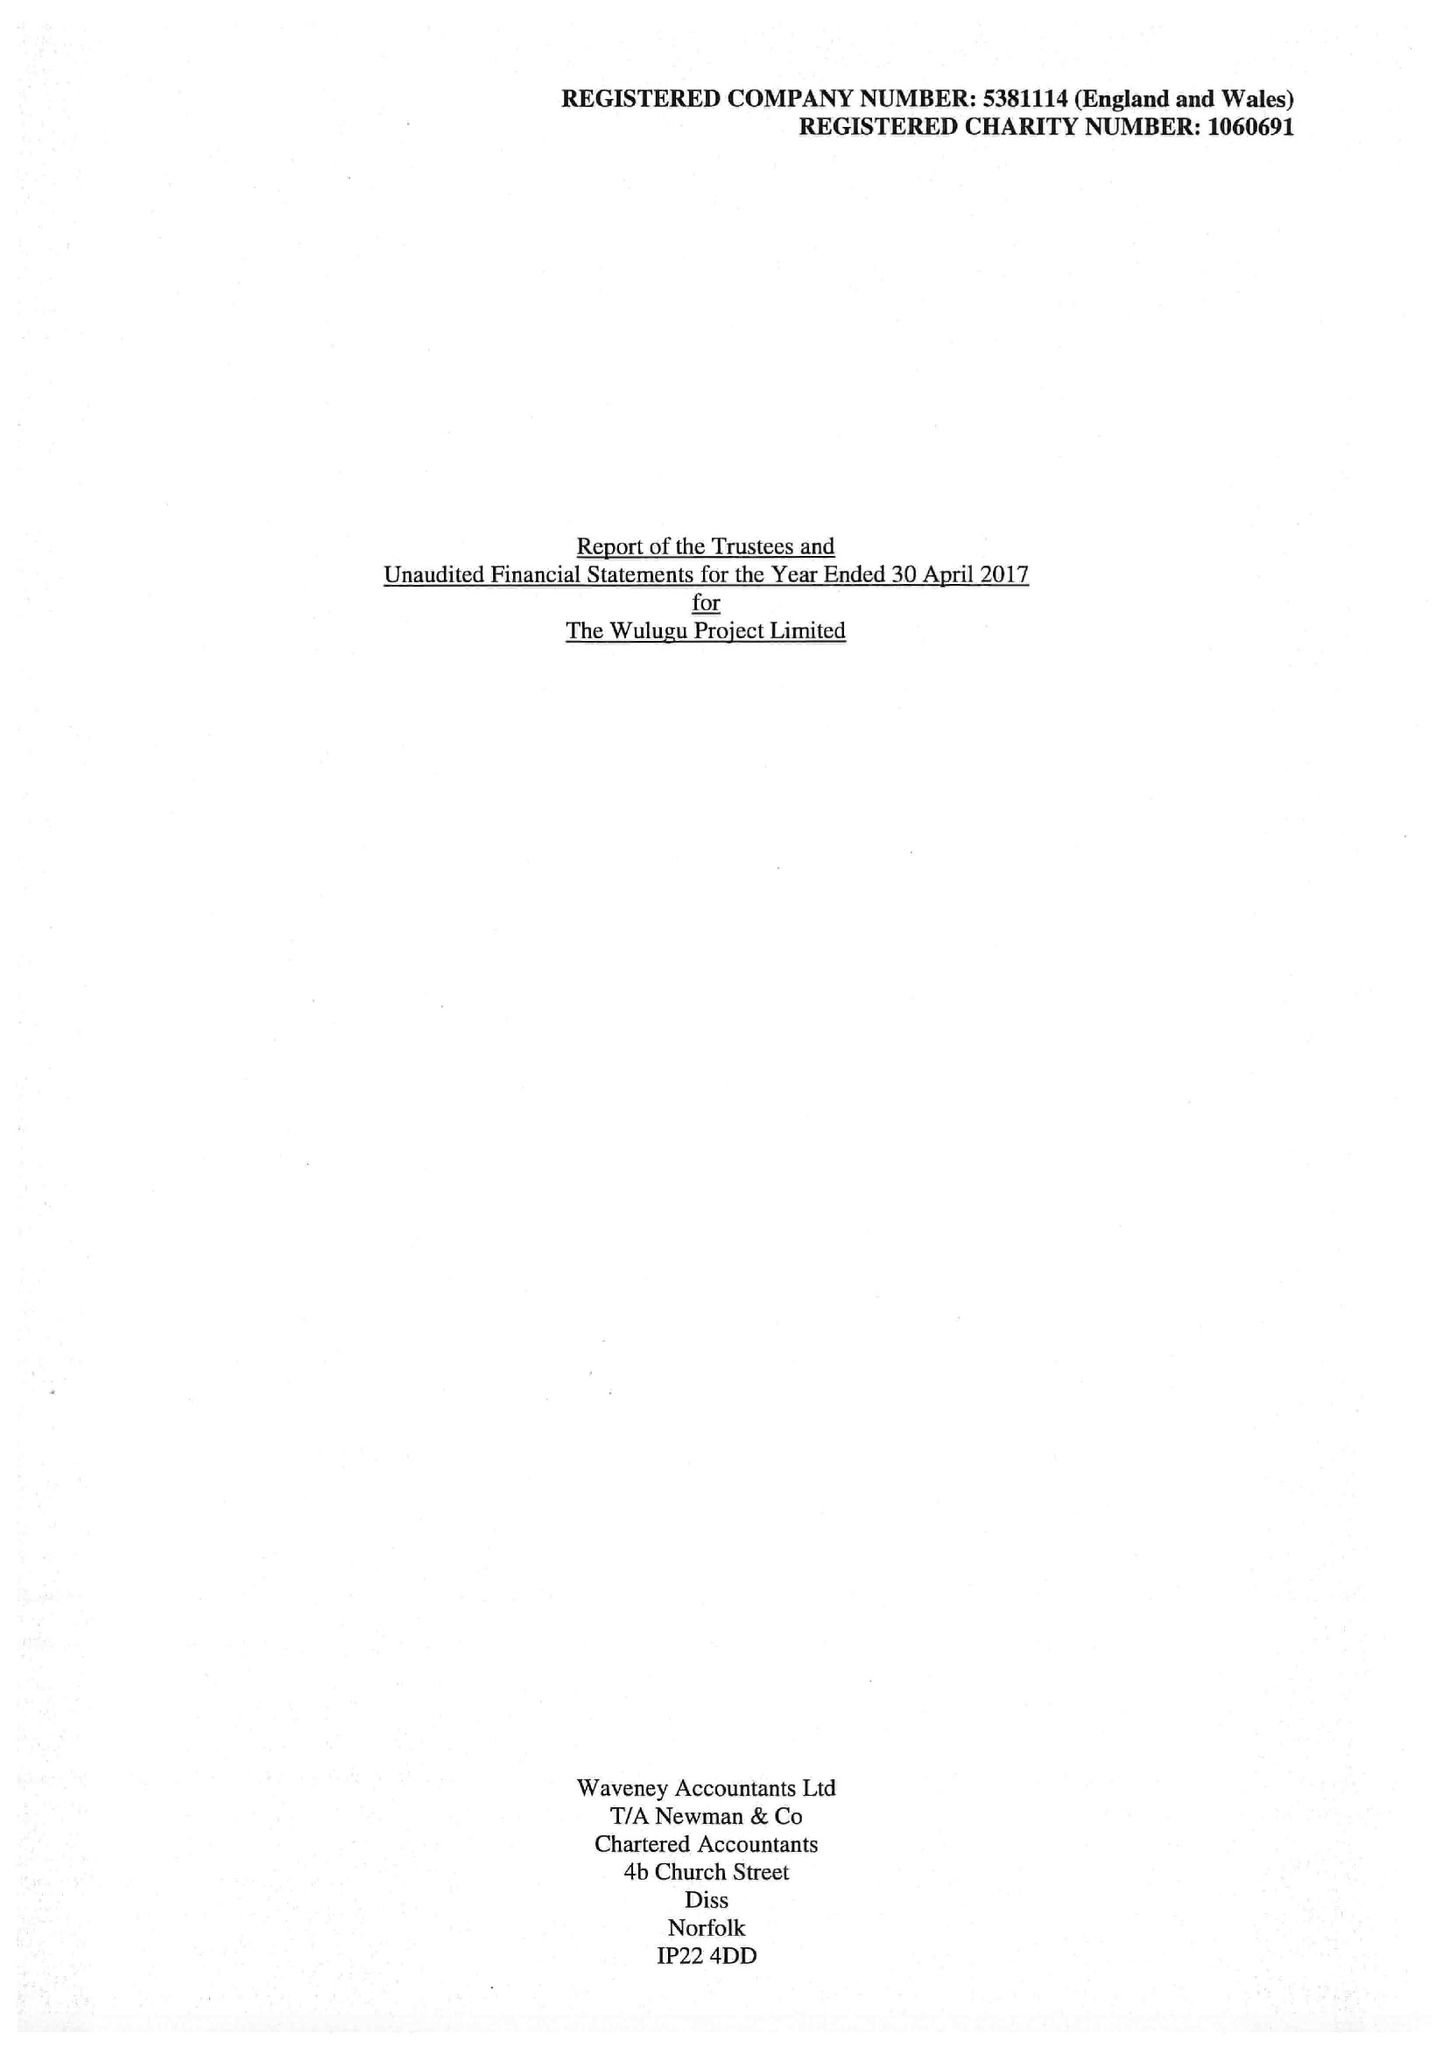What is the value for the report_date?
Answer the question using a single word or phrase. 2017-04-30 